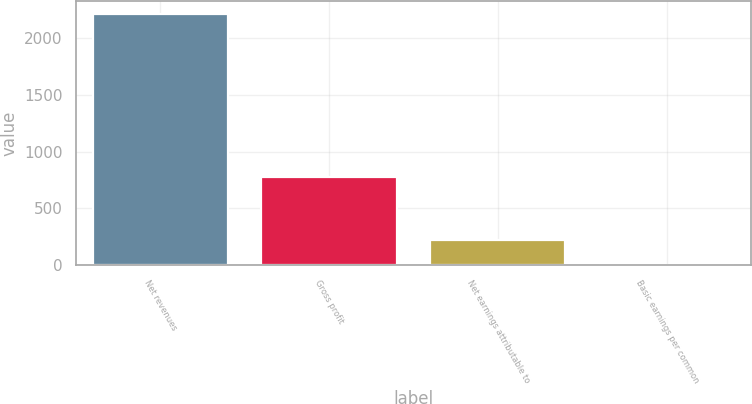Convert chart. <chart><loc_0><loc_0><loc_500><loc_500><bar_chart><fcel>Net revenues<fcel>Gross profit<fcel>Net earnings attributable to<fcel>Basic earnings per common<nl><fcel>2218.7<fcel>772.6<fcel>223.39<fcel>1.69<nl></chart> 